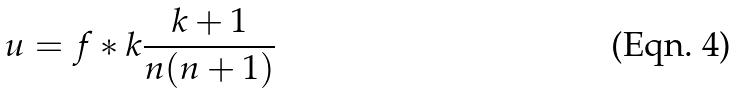Convert formula to latex. <formula><loc_0><loc_0><loc_500><loc_500>u = f * k \frac { k + 1 } { n ( n + 1 ) }</formula> 